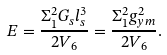<formula> <loc_0><loc_0><loc_500><loc_500>E = \frac { \Sigma _ { 1 } ^ { 2 } G _ { s } l _ { s } ^ { 3 } } { 2 V _ { 6 } } = \frac { \Sigma _ { 1 } ^ { 2 } g _ { y m } ^ { 2 } } { 2 V _ { 6 } } .</formula> 